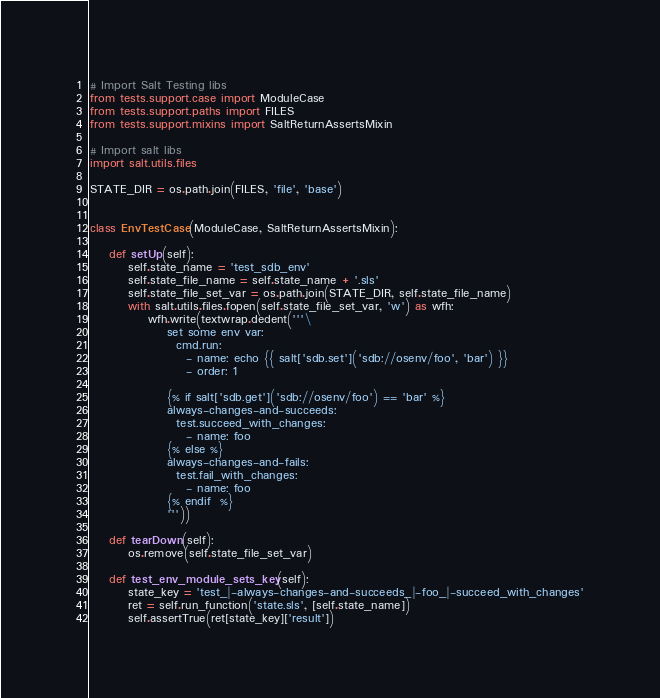Convert code to text. <code><loc_0><loc_0><loc_500><loc_500><_Python_># Import Salt Testing libs
from tests.support.case import ModuleCase
from tests.support.paths import FILES
from tests.support.mixins import SaltReturnAssertsMixin

# Import salt libs
import salt.utils.files

STATE_DIR = os.path.join(FILES, 'file', 'base')


class EnvTestCase(ModuleCase, SaltReturnAssertsMixin):

    def setUp(self):
        self.state_name = 'test_sdb_env'
        self.state_file_name = self.state_name + '.sls'
        self.state_file_set_var = os.path.join(STATE_DIR, self.state_file_name)
        with salt.utils.files.fopen(self.state_file_set_var, 'w') as wfh:
            wfh.write(textwrap.dedent('''\
                set some env var:
                  cmd.run:
                    - name: echo {{ salt['sdb.set']('sdb://osenv/foo', 'bar') }}
                    - order: 1

                {% if salt['sdb.get']('sdb://osenv/foo') == 'bar' %}
                always-changes-and-succeeds:
                  test.succeed_with_changes:
                    - name: foo
                {% else %}
                always-changes-and-fails:
                  test.fail_with_changes:
                    - name: foo
                {% endif  %}
                '''))

    def tearDown(self):
        os.remove(self.state_file_set_var)

    def test_env_module_sets_key(self):
        state_key = 'test_|-always-changes-and-succeeds_|-foo_|-succeed_with_changes'
        ret = self.run_function('state.sls', [self.state_name])
        self.assertTrue(ret[state_key]['result'])
</code> 